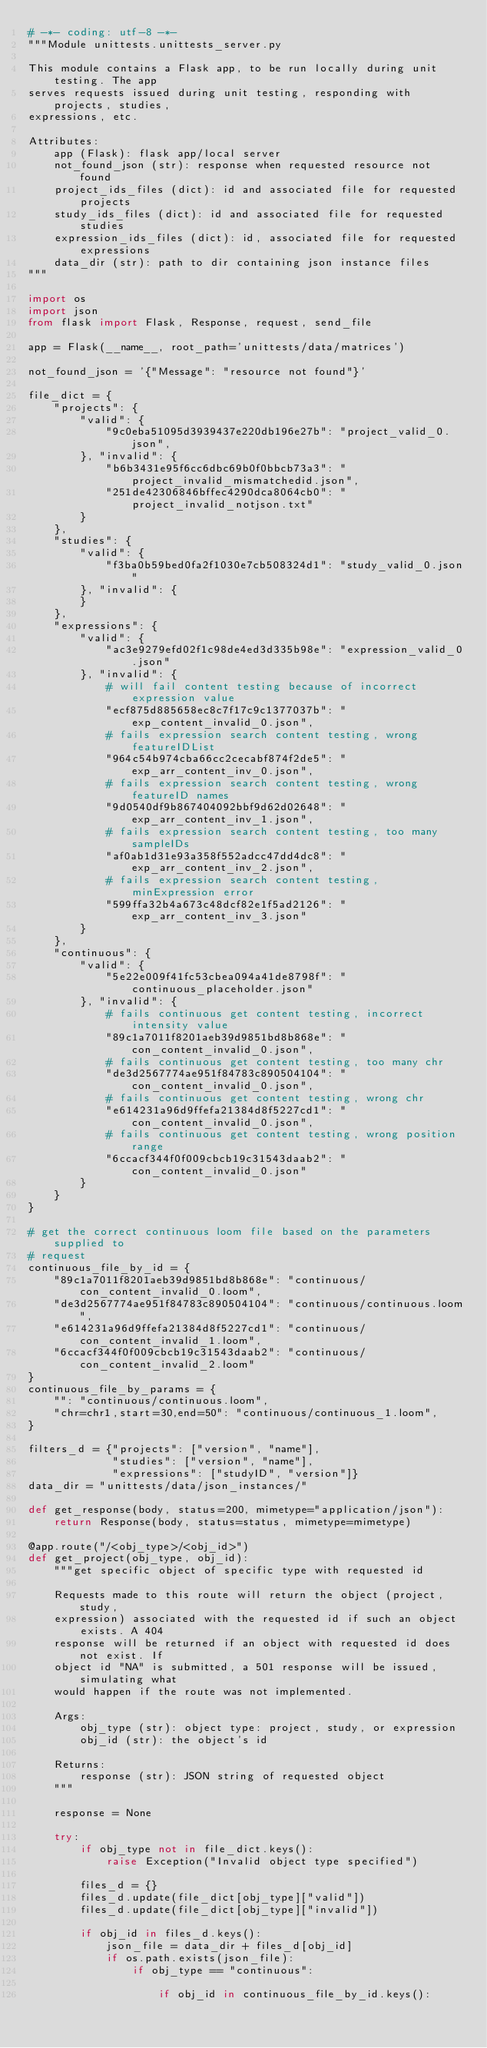<code> <loc_0><loc_0><loc_500><loc_500><_Python_># -*- coding: utf-8 -*-
"""Module unittests.unittests_server.py

This module contains a Flask app, to be run locally during unit testing. The app
serves requests issued during unit testing, responding with projects, studies,
expressions, etc.

Attributes:
    app (Flask): flask app/local server
    not_found_json (str): response when requested resource not found
    project_ids_files (dict): id and associated file for requested projects
    study_ids_files (dict): id and associated file for requested studies
    expression_ids_files (dict): id, associated file for requested expressions
    data_dir (str): path to dir containing json instance files
"""

import os
import json
from flask import Flask, Response, request, send_file

app = Flask(__name__, root_path='unittests/data/matrices')

not_found_json = '{"Message": "resource not found"}'

file_dict = {
    "projects": {
        "valid": {
            "9c0eba51095d3939437e220db196e27b": "project_valid_0.json",
        }, "invalid": {
            "b6b3431e95f6cc6dbc69b0f0bbcb73a3": "project_invalid_mismatchedid.json",
            "251de42306846bffec4290dca8064cb0": "project_invalid_notjson.txt"
        }
    },
    "studies": {
        "valid": {
            "f3ba0b59bed0fa2f1030e7cb508324d1": "study_valid_0.json"
        }, "invalid": {
        }
    },
    "expressions": {
        "valid": {
            "ac3e9279efd02f1c98de4ed3d335b98e": "expression_valid_0.json"
        }, "invalid": {
            # will fail content testing because of incorrect expression value
            "ecf875d885658ec8c7f17c9c1377037b": "exp_content_invalid_0.json",
            # fails expression search content testing, wrong featureIDList
            "964c54b974cba66cc2cecabf874f2de5": "exp_arr_content_inv_0.json",
            # fails expression search content testing, wrong featureID names
            "9d0540df9b867404092bbf9d62d02648": "exp_arr_content_inv_1.json",
            # fails expression search content testing, too many sampleIDs
            "af0ab1d31e93a358f552adcc47dd4dc8": "exp_arr_content_inv_2.json",
            # fails expression search content testing, minExpression error
            "599ffa32b4a673c48dcf82e1f5ad2126": "exp_arr_content_inv_3.json"
        }
    },
    "continuous": {
        "valid": {
            "5e22e009f41fc53cbea094a41de8798f": "continuous_placeholder.json"
        }, "invalid": {
            # fails continuous get content testing, incorrect intensity value
            "89c1a7011f8201aeb39d9851bd8b868e": "con_content_invalid_0.json",
            # fails continuous get content testing, too many chr
            "de3d2567774ae951f84783c890504104": "con_content_invalid_0.json",
            # fails continuous get content testing, wrong chr 
            "e614231a96d9ffefa21384d8f5227cd1": "con_content_invalid_0.json",
            # fails continuous get content testing, wrong position range
            "6ccacf344f0f009cbcb19c31543daab2": "con_content_invalid_0.json"
        }
    }
}

# get the correct continuous loom file based on the parameters supplied to 
# request
continuous_file_by_id = {
    "89c1a7011f8201aeb39d9851bd8b868e": "continuous/con_content_invalid_0.loom",
    "de3d2567774ae951f84783c890504104": "continuous/continuous.loom",
    "e614231a96d9ffefa21384d8f5227cd1": "continuous/con_content_invalid_1.loom",
    "6ccacf344f0f009cbcb19c31543daab2": "continuous/con_content_invalid_2.loom"
}
continuous_file_by_params = {
    "": "continuous/continuous.loom",
    "chr=chr1,start=30,end=50": "continuous/continuous_1.loom",
}

filters_d = {"projects": ["version", "name"],
             "studies": ["version", "name"],
             "expressions": ["studyID", "version"]}
data_dir = "unittests/data/json_instances/"

def get_response(body, status=200, mimetype="application/json"):
    return Response(body, status=status, mimetype=mimetype)

@app.route("/<obj_type>/<obj_id>")
def get_project(obj_type, obj_id):
    """get specific object of specific type with requested id

    Requests made to this route will return the object (project, study, 
    expression) associated with the requested id if such an object exists. A 404
    response will be returned if an object with requested id does not exist. If
    object id "NA" is submitted, a 501 response will be issued, simulating what
    would happen if the route was not implemented.

    Args:
        obj_type (str): object type: project, study, or expression
        obj_id (str): the object's id
    
    Returns:
        response (str): JSON string of requested object
    """
    
    response = None

    try:
        if obj_type not in file_dict.keys():
            raise Exception("Invalid object type specified")

        files_d = {}
        files_d.update(file_dict[obj_type]["valid"])
        files_d.update(file_dict[obj_type]["invalid"])

        if obj_id in files_d.keys():
            json_file = data_dir + files_d[obj_id]
            if os.path.exists(json_file):
                if obj_type == "continuous":

                    if obj_id in continuous_file_by_id.keys():</code> 